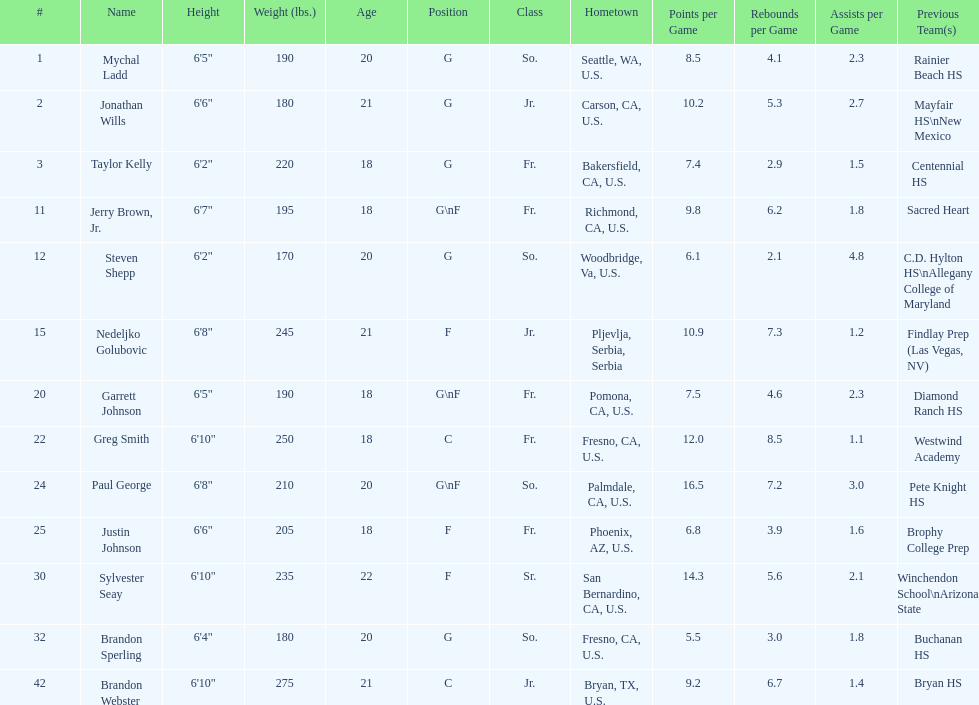Which player previously played for sacred heart? Jerry Brown, Jr. 